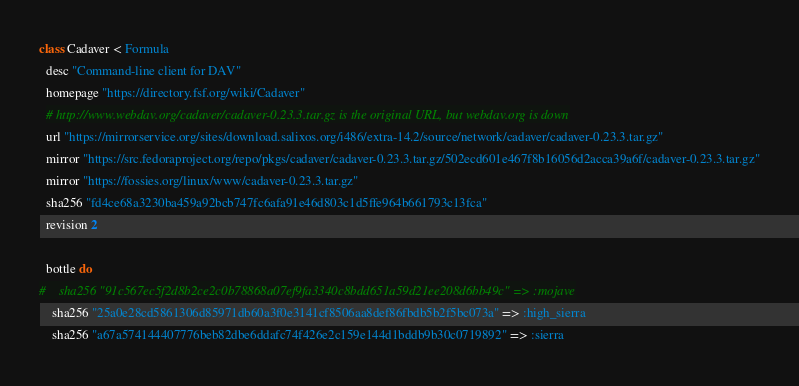<code> <loc_0><loc_0><loc_500><loc_500><_Ruby_>class Cadaver < Formula
  desc "Command-line client for DAV"
  homepage "https://directory.fsf.org/wiki/Cadaver"
  # http://www.webdav.org/cadaver/cadaver-0.23.3.tar.gz is the original URL, but webdav.org is down
  url "https://mirrorservice.org/sites/download.salixos.org/i486/extra-14.2/source/network/cadaver/cadaver-0.23.3.tar.gz"
  mirror "https://src.fedoraproject.org/repo/pkgs/cadaver/cadaver-0.23.3.tar.gz/502ecd601e467f8b16056d2acca39a6f/cadaver-0.23.3.tar.gz"
  mirror "https://fossies.org/linux/www/cadaver-0.23.3.tar.gz"
  sha256 "fd4ce68a3230ba459a92bcb747fc6afa91e46d803c1d5ffe964b661793c13fca"
  revision 2

  bottle do
#    sha256 "91c567ec5f2d8b2ce2c0b78868a07ef9fa3340c8bdd651a59d21ee208d6bb49c" => :mojave
    sha256 "25a0e28cd5861306d85971db60a3f0e3141cf8506aa8def86fbdb5b2f5bc073a" => :high_sierra
    sha256 "a67a574144407776beb82dbe6ddafc74f426e2c159e144d1bddb9b30c0719892" => :sierra</code> 